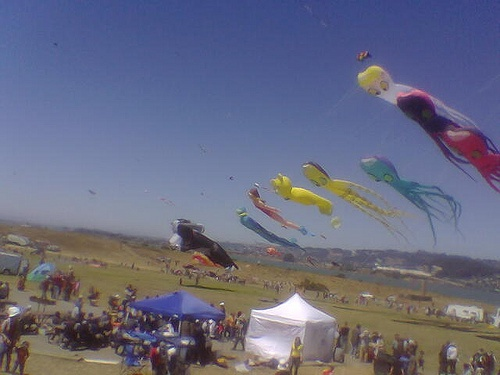Describe the objects in this image and their specific colors. I can see people in blue, gray, maroon, and black tones, kite in blue, purple, gray, and black tones, kite in blue and gray tones, kite in blue, gray, and olive tones, and kite in blue, black, gray, and darkgray tones in this image. 